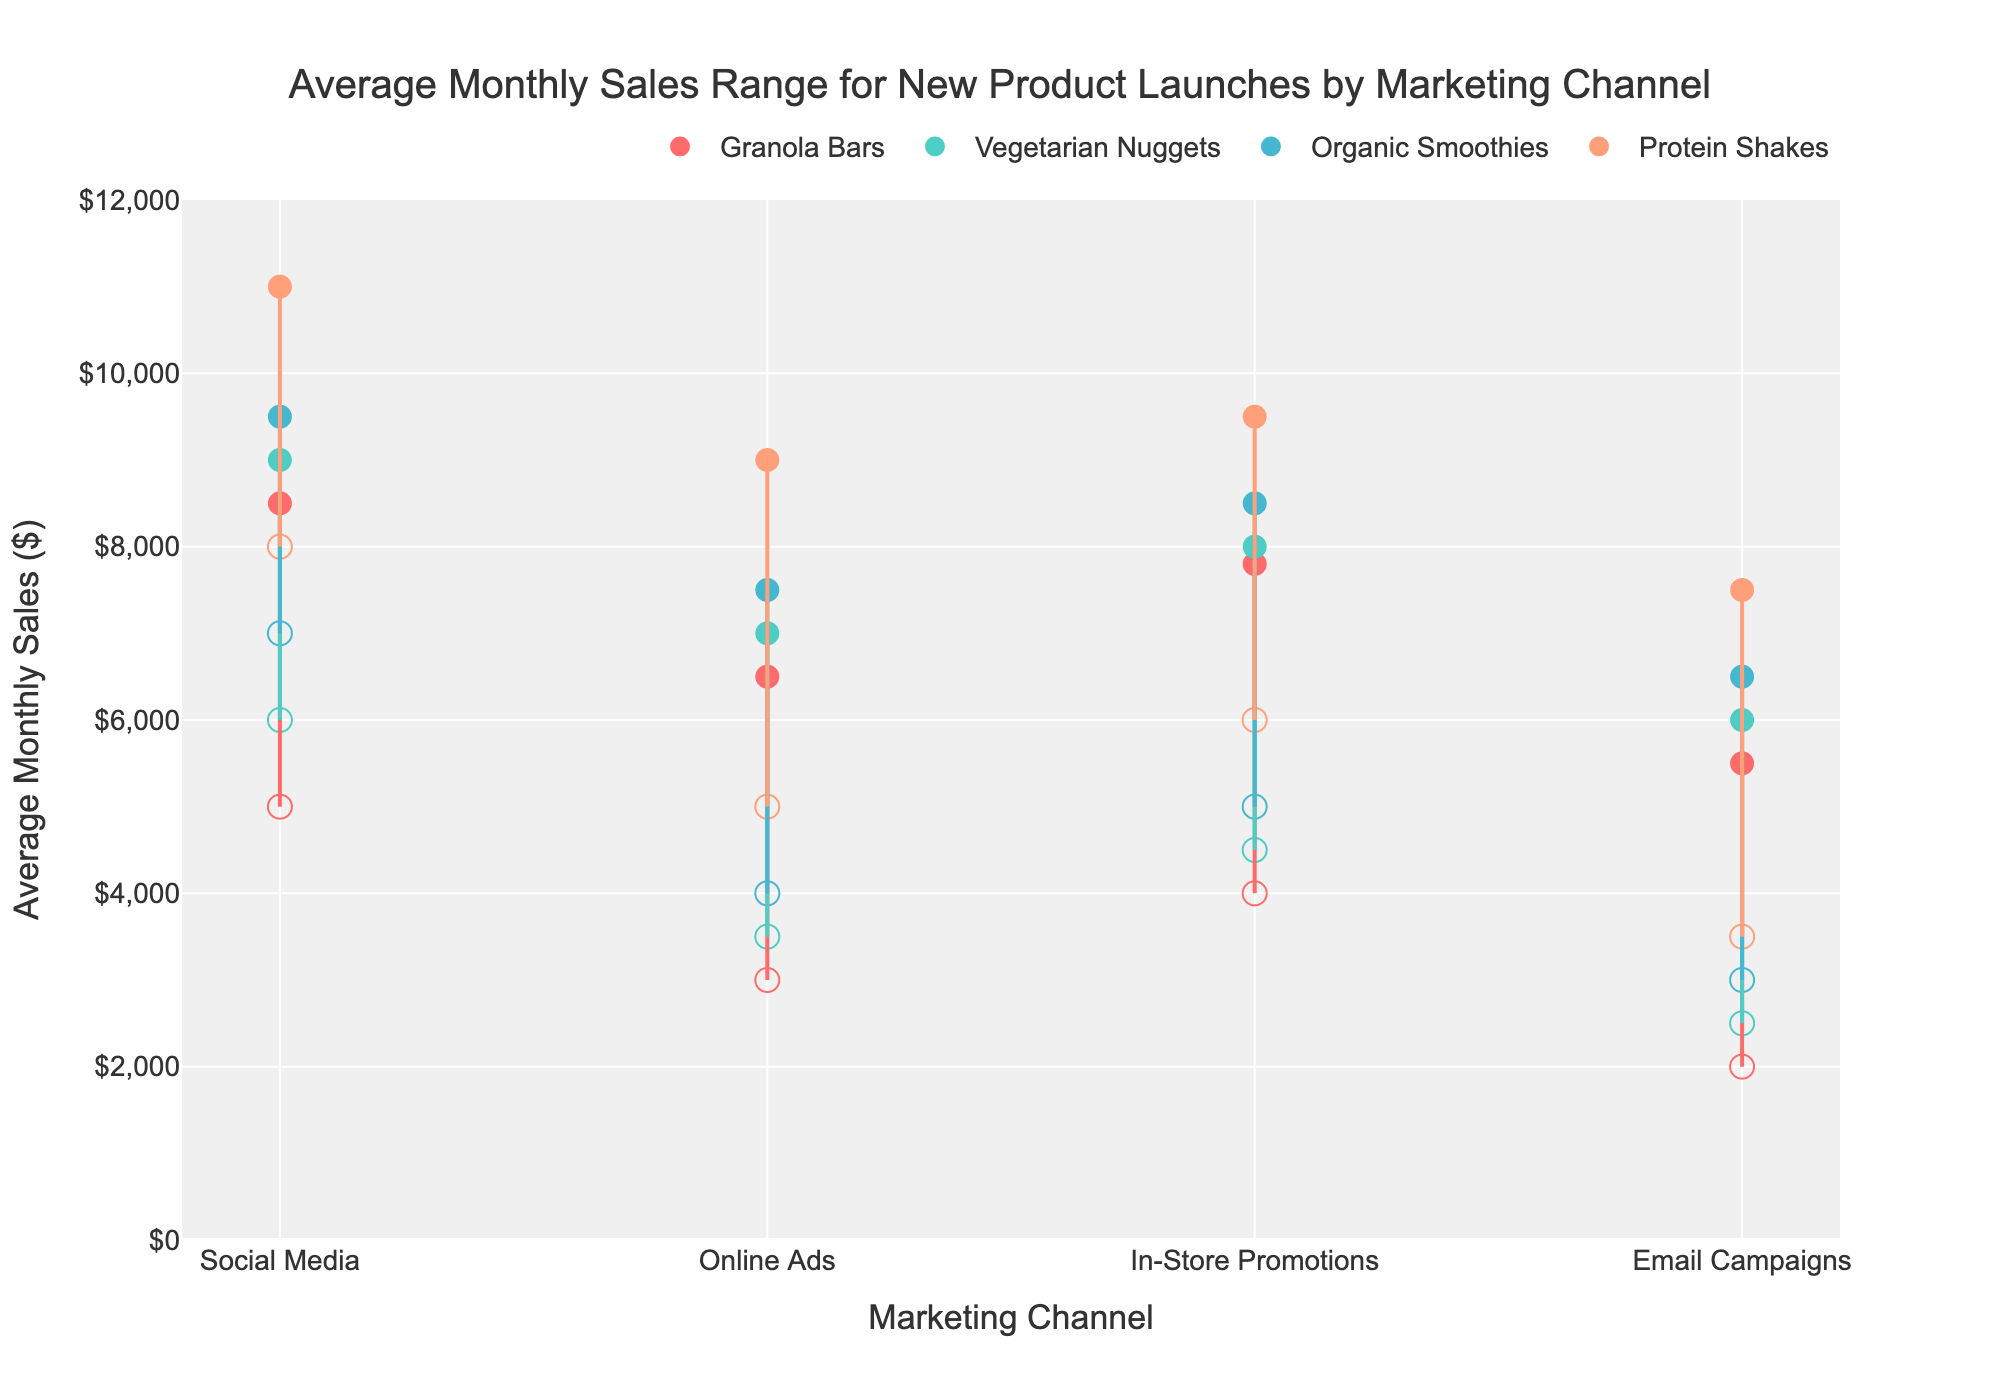What is the maximum average monthly sales for Protein Shakes through Social Media? The maximum average monthly sales for Protein Shakes through Social Media can be found by looking for the highest data point in the range for Protein Shakes in the 'Social Media' category.
Answer: 11000 Which product has the highest minimum sales through Email Campaigns? The minimum sales data points for all products through Email Campaigns are: Granola Bars (2000), Vegetarian Nuggets (2500), Organic Smoothies (3000), Protein Shakes (3500). The highest minimum value is 3500.
Answer: Protein Shakes What is the difference between the maximum and minimum sales for Organic Smoothies through In-Store Promotions? The difference can be calculated as Max - Min for Organic Smoothies in the 'In-Store Promotions' category. These values are 8500 and 5000, respectively, so the difference is 8500 - 5000.
Answer: 3500 Which marketing channel has the highest range in sales for Granola Bars? The range in sales for each marketing channel for Granola Bars can be calculated as Max - Min for each. Social Media (8500-5000 = 3500), Online Ads (6500-3000 = 3500), In-Store Promotions (7800-4000 = 3800), Email Campaigns (5500-2000 = 3500). The highest range is 3800.
Answer: In-Store Promotions How do the maximum sales for Vegetarian Nuggets through Social Media compare to Protein Shakes through Online Ads? The maximum sales for Vegetarian Nuggets through Social Media is 9000, and for Protein Shakes through Online Ads, it is also 9000. Comparing the two, they are equal.
Answer: Equal What is the average of the minimum sales values for all the products through Online Ads? The minimum sales values for Online Ads for each product are Granola Bars (3000), Vegetarian Nuggets (3500), Organic Smoothies (4000), Protein Shakes (5000). Sum these values: 3000 + 3500 + 4000 + 5000 = 15500. The average is 15500 / 4.
Answer: 3875 Which product has the smallest sales range through In-Store Promotions? Calculate the sales range for each product in the 'In-Store Promotions' category (Max - Min): Granola Bars (7800-4000 = 3800), Vegetarian Nuggets (8000-4500 = 3500), Organic Smoothies (8500-5000 = 3500), Protein Shakes (9500-6000 = 3500). The smallest range is 3500.
Answer: Vegetarian Nuggets Which marketing channel generally exhibits the smallest variation in sales across all products? To determine the smallest variation, calculate the range for each marketing channel across all products and then compare them. Social Media (3500, 3000, 2500, 3000), Online Ads (3500, 3500, 3500, 4000), In-Store Promotions (3800, 3500, 3500, 3500), Email Campaigns (3500, 3500, 3500, 4000). The smallest range is consistently 3000.
Answer: Social Media 